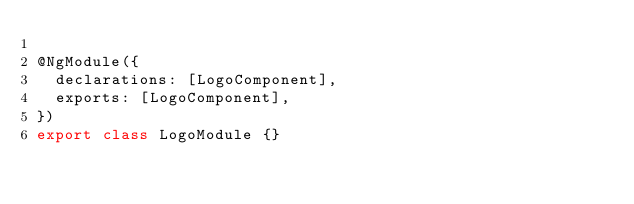Convert code to text. <code><loc_0><loc_0><loc_500><loc_500><_TypeScript_>
@NgModule({
  declarations: [LogoComponent],
  exports: [LogoComponent],
})
export class LogoModule {}
</code> 